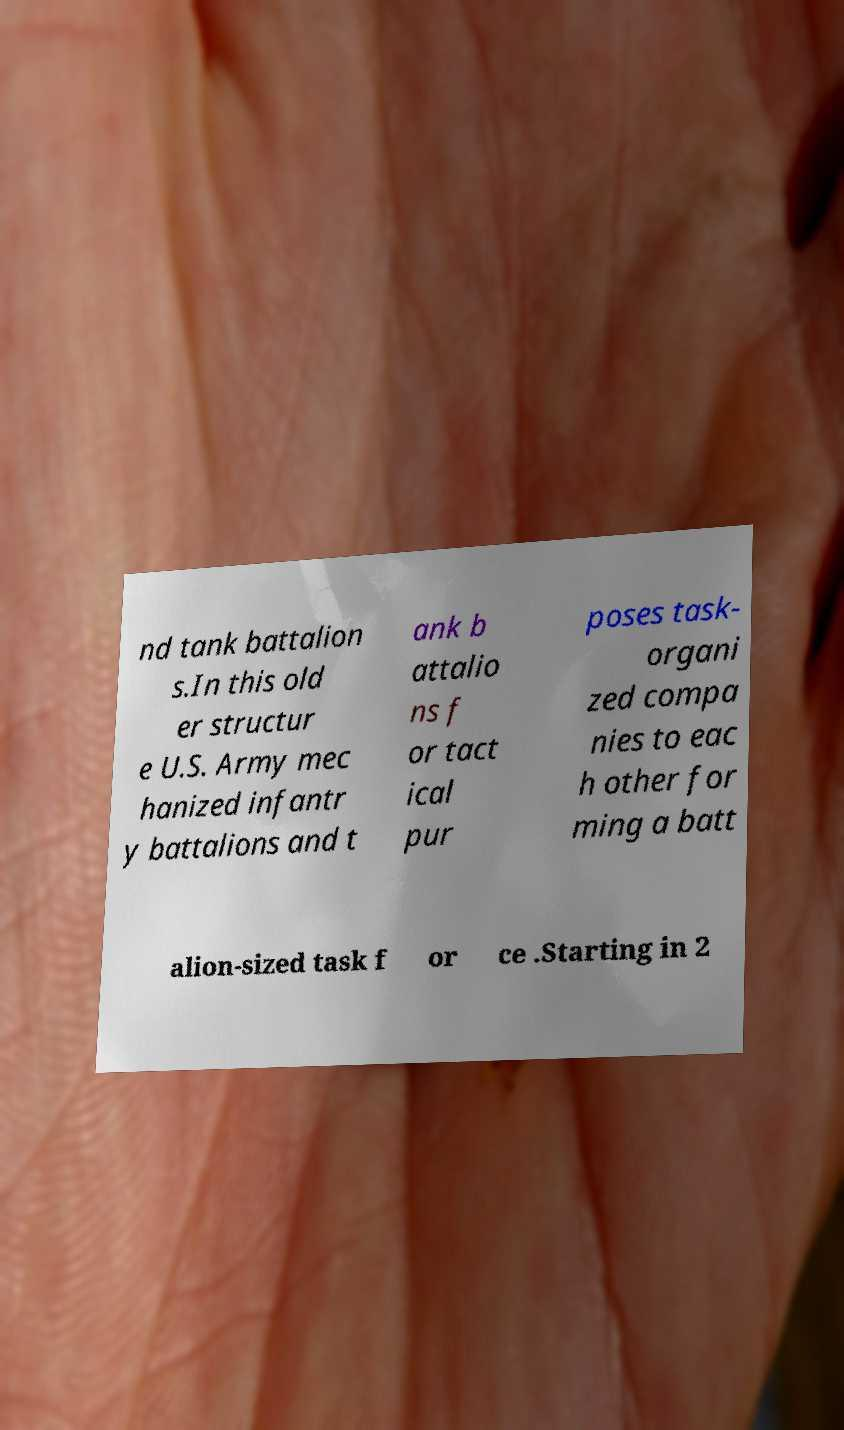Could you extract and type out the text from this image? nd tank battalion s.In this old er structur e U.S. Army mec hanized infantr y battalions and t ank b attalio ns f or tact ical pur poses task- organi zed compa nies to eac h other for ming a batt alion-sized task f or ce .Starting in 2 